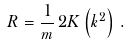Convert formula to latex. <formula><loc_0><loc_0><loc_500><loc_500>R = \frac { 1 } { m } \, 2 K \left ( k ^ { 2 } \right ) \, .</formula> 